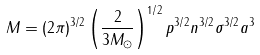Convert formula to latex. <formula><loc_0><loc_0><loc_500><loc_500>M = ( 2 \pi ) ^ { 3 / 2 } \left ( \frac { 2 } { 3 M _ { \odot } } \right ) ^ { 1 / 2 } p ^ { 3 / 2 } n ^ { 3 / 2 } \sigma ^ { 3 / 2 } a ^ { 3 }</formula> 